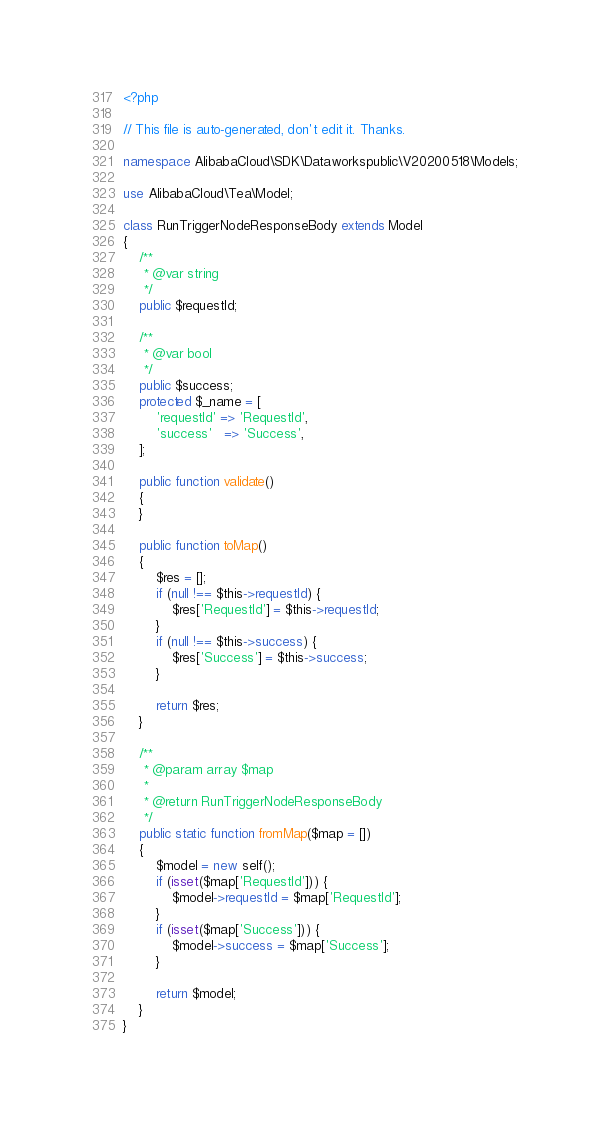Convert code to text. <code><loc_0><loc_0><loc_500><loc_500><_PHP_><?php

// This file is auto-generated, don't edit it. Thanks.

namespace AlibabaCloud\SDK\Dataworkspublic\V20200518\Models;

use AlibabaCloud\Tea\Model;

class RunTriggerNodeResponseBody extends Model
{
    /**
     * @var string
     */
    public $requestId;

    /**
     * @var bool
     */
    public $success;
    protected $_name = [
        'requestId' => 'RequestId',
        'success'   => 'Success',
    ];

    public function validate()
    {
    }

    public function toMap()
    {
        $res = [];
        if (null !== $this->requestId) {
            $res['RequestId'] = $this->requestId;
        }
        if (null !== $this->success) {
            $res['Success'] = $this->success;
        }

        return $res;
    }

    /**
     * @param array $map
     *
     * @return RunTriggerNodeResponseBody
     */
    public static function fromMap($map = [])
    {
        $model = new self();
        if (isset($map['RequestId'])) {
            $model->requestId = $map['RequestId'];
        }
        if (isset($map['Success'])) {
            $model->success = $map['Success'];
        }

        return $model;
    }
}
</code> 